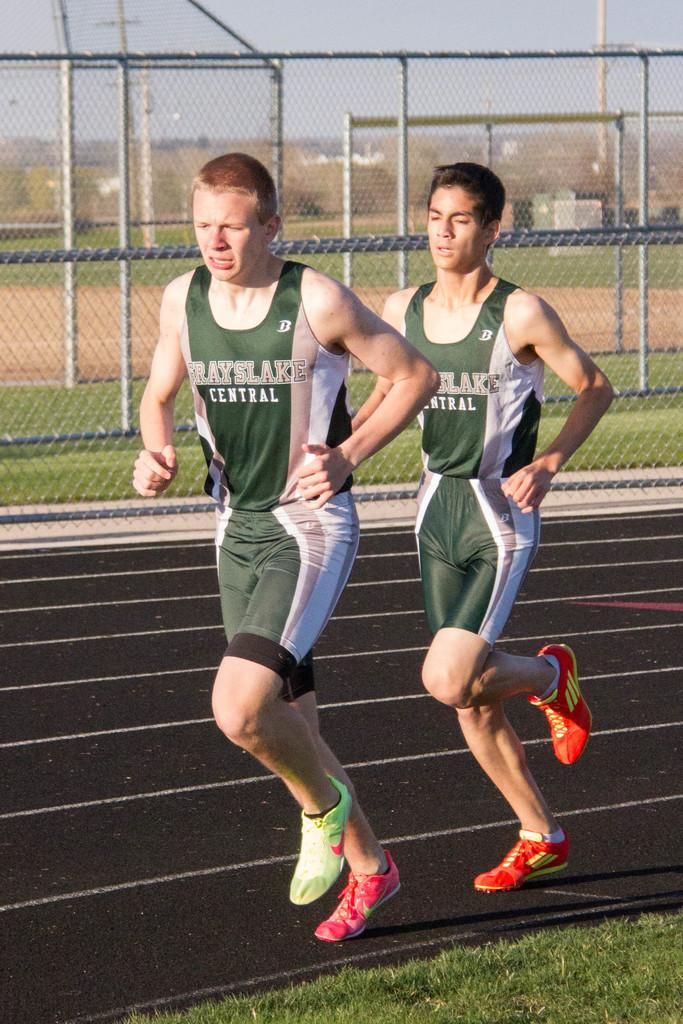Provide a one-sentence caption for the provided image. Two kids running a track with a Grayslake Central jersey. 